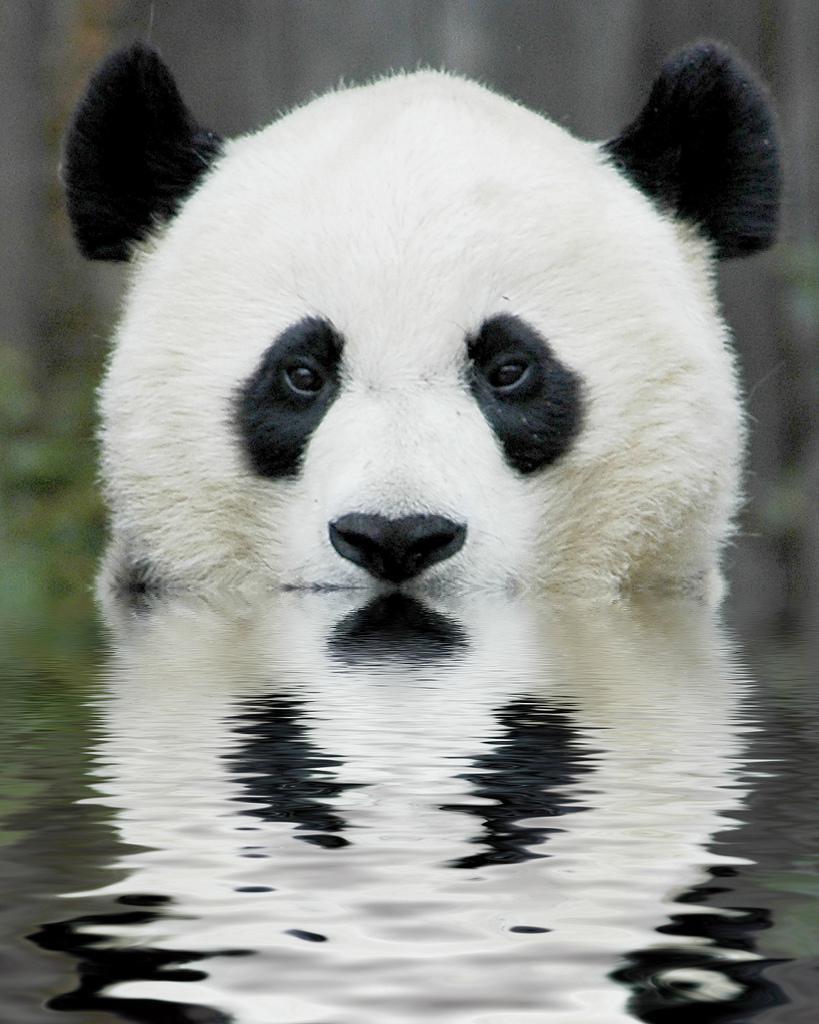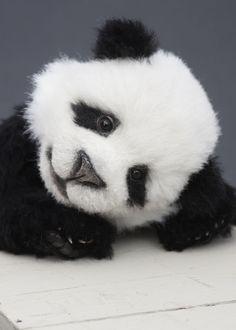The first image is the image on the left, the second image is the image on the right. Analyze the images presented: Is the assertion "A panda has its head on the floor in the right image." valid? Answer yes or no. Yes. 